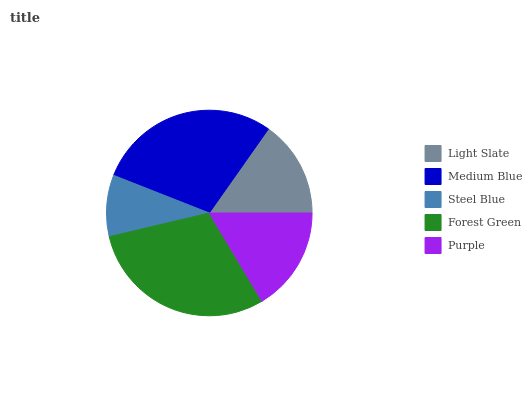Is Steel Blue the minimum?
Answer yes or no. Yes. Is Forest Green the maximum?
Answer yes or no. Yes. Is Medium Blue the minimum?
Answer yes or no. No. Is Medium Blue the maximum?
Answer yes or no. No. Is Medium Blue greater than Light Slate?
Answer yes or no. Yes. Is Light Slate less than Medium Blue?
Answer yes or no. Yes. Is Light Slate greater than Medium Blue?
Answer yes or no. No. Is Medium Blue less than Light Slate?
Answer yes or no. No. Is Purple the high median?
Answer yes or no. Yes. Is Purple the low median?
Answer yes or no. Yes. Is Steel Blue the high median?
Answer yes or no. No. Is Medium Blue the low median?
Answer yes or no. No. 